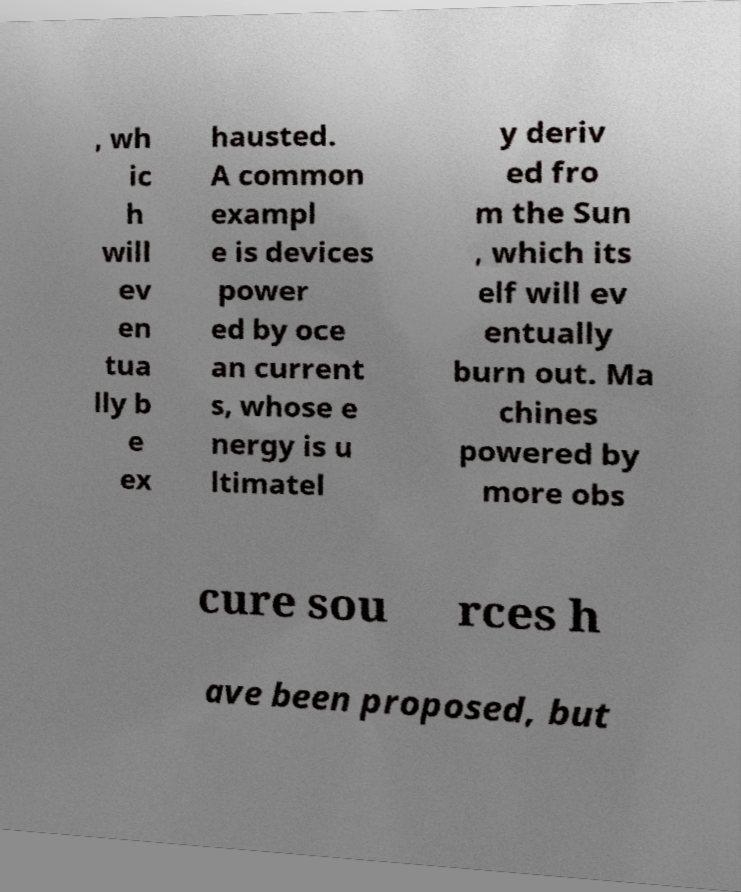I need the written content from this picture converted into text. Can you do that? , wh ic h will ev en tua lly b e ex hausted. A common exampl e is devices power ed by oce an current s, whose e nergy is u ltimatel y deriv ed fro m the Sun , which its elf will ev entually burn out. Ma chines powered by more obs cure sou rces h ave been proposed, but 